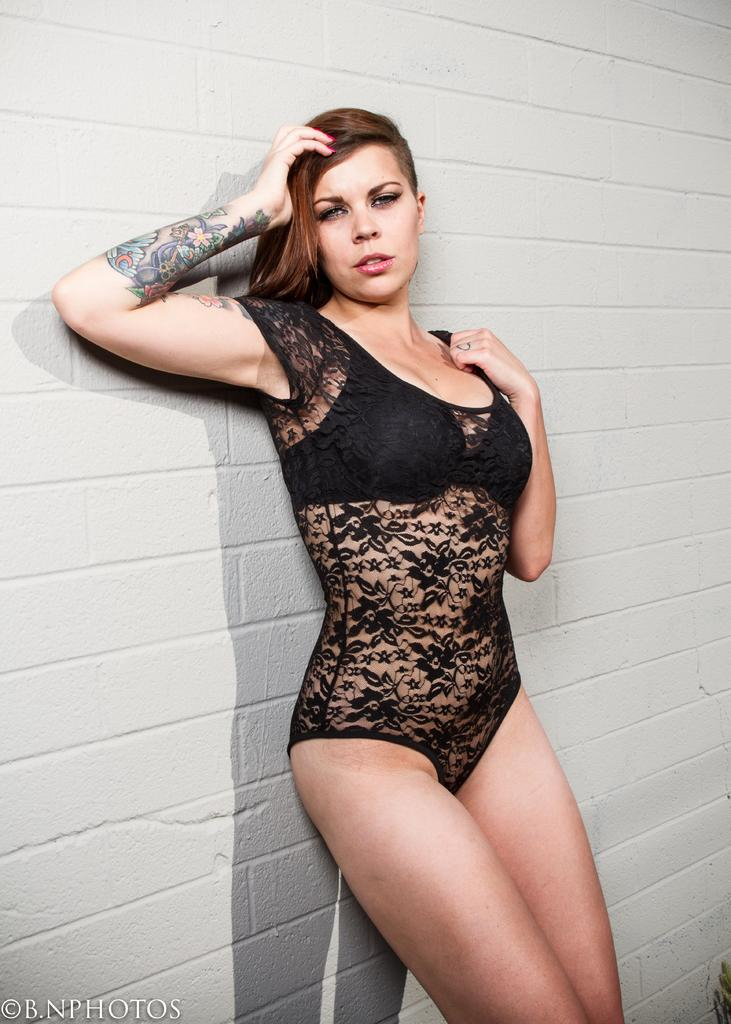What is the main subject of the image? There is a woman standing in the image. What can be seen behind the woman? There is a wall visible behind the woman. Is there any additional information about the image's quality or condition? Yes, there is a water mark in the bottom left corner of the image. What position does the woman hold in the company she works for? The image does not provide any information about the woman's position in a company. How does the woman feel about her crush in the image? The image does not provide any information about the woman's feelings towards a crush. 